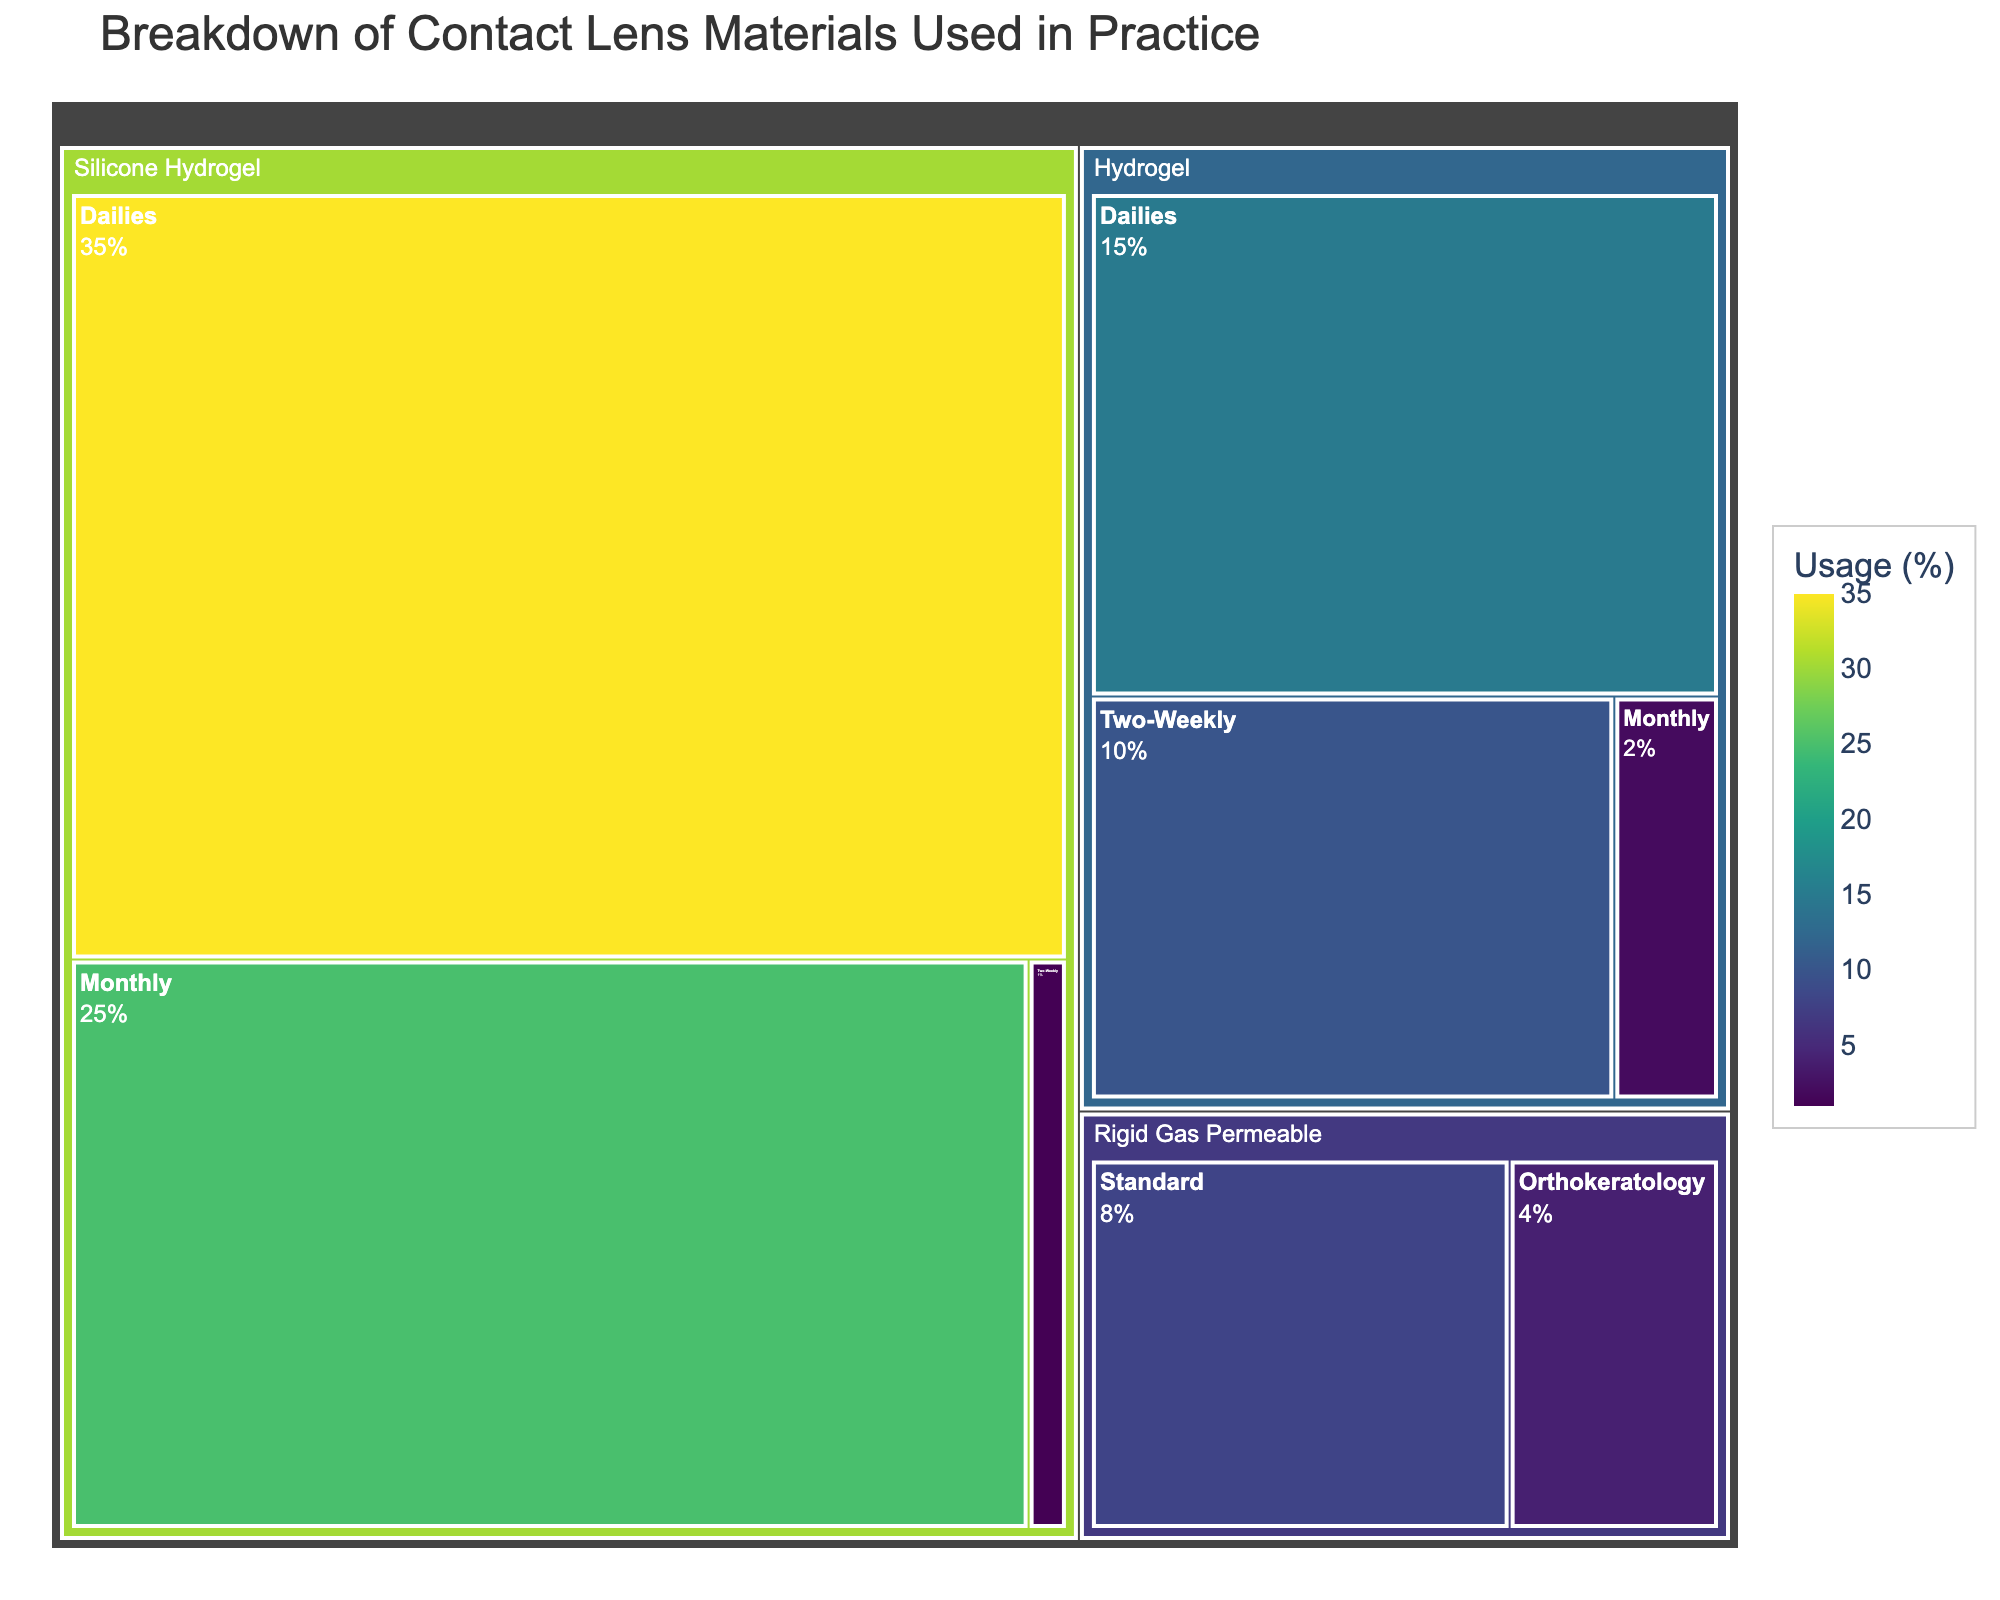What is the title of the treemap? The title of the treemap is usually displayed prominently at the top of the figure.
Answer: Breakdown of Contact Lens Materials Used in Practice Which contact lens material has the highest usage? The largest section in the treemap corresponds to the material with the highest usage.
Answer: Silicone Hydrogel (Dailies) What percentage of contact lenses used are Rigid Gas Permeable (Orthokeratology)? The section labeled "Rigid Gas Permeable" under "Orthokeratology" shows the exact percentage.
Answer: 4% Which type of Hydrogel lenses has the lowest usage? Among the Hydrogel sections, look for the smallest one or the one with the smallest percentage.
Answer: Monthly (2%) How does the usage of Silicone Hydrogel (Monthly) compare to Hydrogel (Dailies)? Compare the percentages of the sections labeled "Silicone Hydrogel (Monthly)" and "Hydrogel (Dailies)."
Answer: Silicone Hydrogel (Monthly) has a higher usage at 25% compared to Hydrogel (Dailies) at 15% What is the combined usage percentage of all Hydrogel contact lenses? Add the usage percentages of all types under Hydrogel (Dailies, Two-Weekly, and Monthly).
Answer: 15% + 10% + 2% = 27% Which type of Silicone Hydrogel lens has the lowest usage? Among the Silicone Hydrogel sections, identify the one with the smallest percentage.
Answer: Two-Weekly (1%) Are there more Two-Weekly lenses made of Silicone Hydrogel or Hydrogel? Compare the sections labeled "Silicone Hydrogel (Two-Weekly)" and "Hydrogel (Two-Weekly)."
Answer: Hydrogel (Two-Weekly) has more usage at 10% What is the total usage of contact lenses that are not Rigid Gas Permeable? Subtract the combined usage percentage of all Rigid Gas Permeable types (Standard and Orthokeratology) from 100%.
Answer: 100% - (8% + 4%) = 88% What is the most common type of contact lens used? Identify the section with the largest percentage overall.
Answer: Silicone Hydrogel (Dailies) 